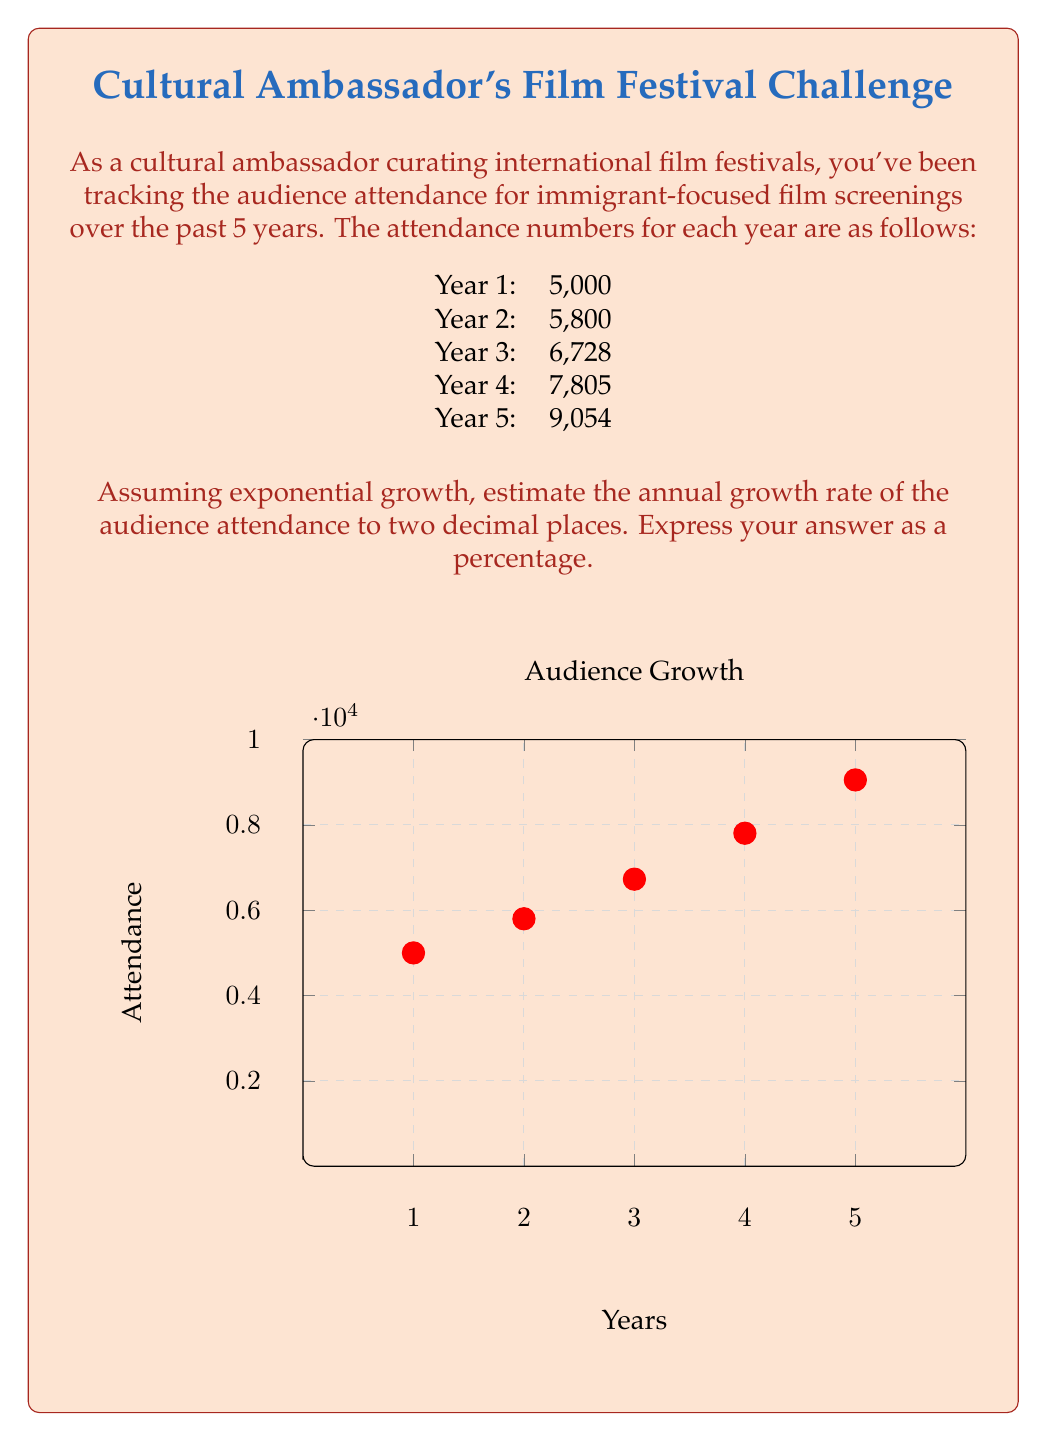Can you solve this math problem? To estimate the annual growth rate assuming exponential growth, we can use the formula:

$$A_n = A_0(1+r)^n$$

Where:
$A_n$ is the final value
$A_0$ is the initial value
$r$ is the growth rate
$n$ is the number of periods

In this case:
$A_0 = 5000$ (Year 1 attendance)
$A_n = 9054$ (Year 5 attendance)
$n = 4$ (number of growth periods from Year 1 to Year 5)

Substituting these values:

$$9054 = 5000(1+r)^4$$

Dividing both sides by 5000:

$$1.8108 = (1+r)^4$$

Taking the fourth root of both sides:

$$\sqrt[4]{1.8108} = 1+r$$

$$1.1602 = 1+r$$

Subtracting 1 from both sides:

$$r = 0.1602$$

Converting to a percentage:

$$r = 16.02\%$$

Therefore, the estimated annual growth rate is 16.02%.
Answer: 16.02% 